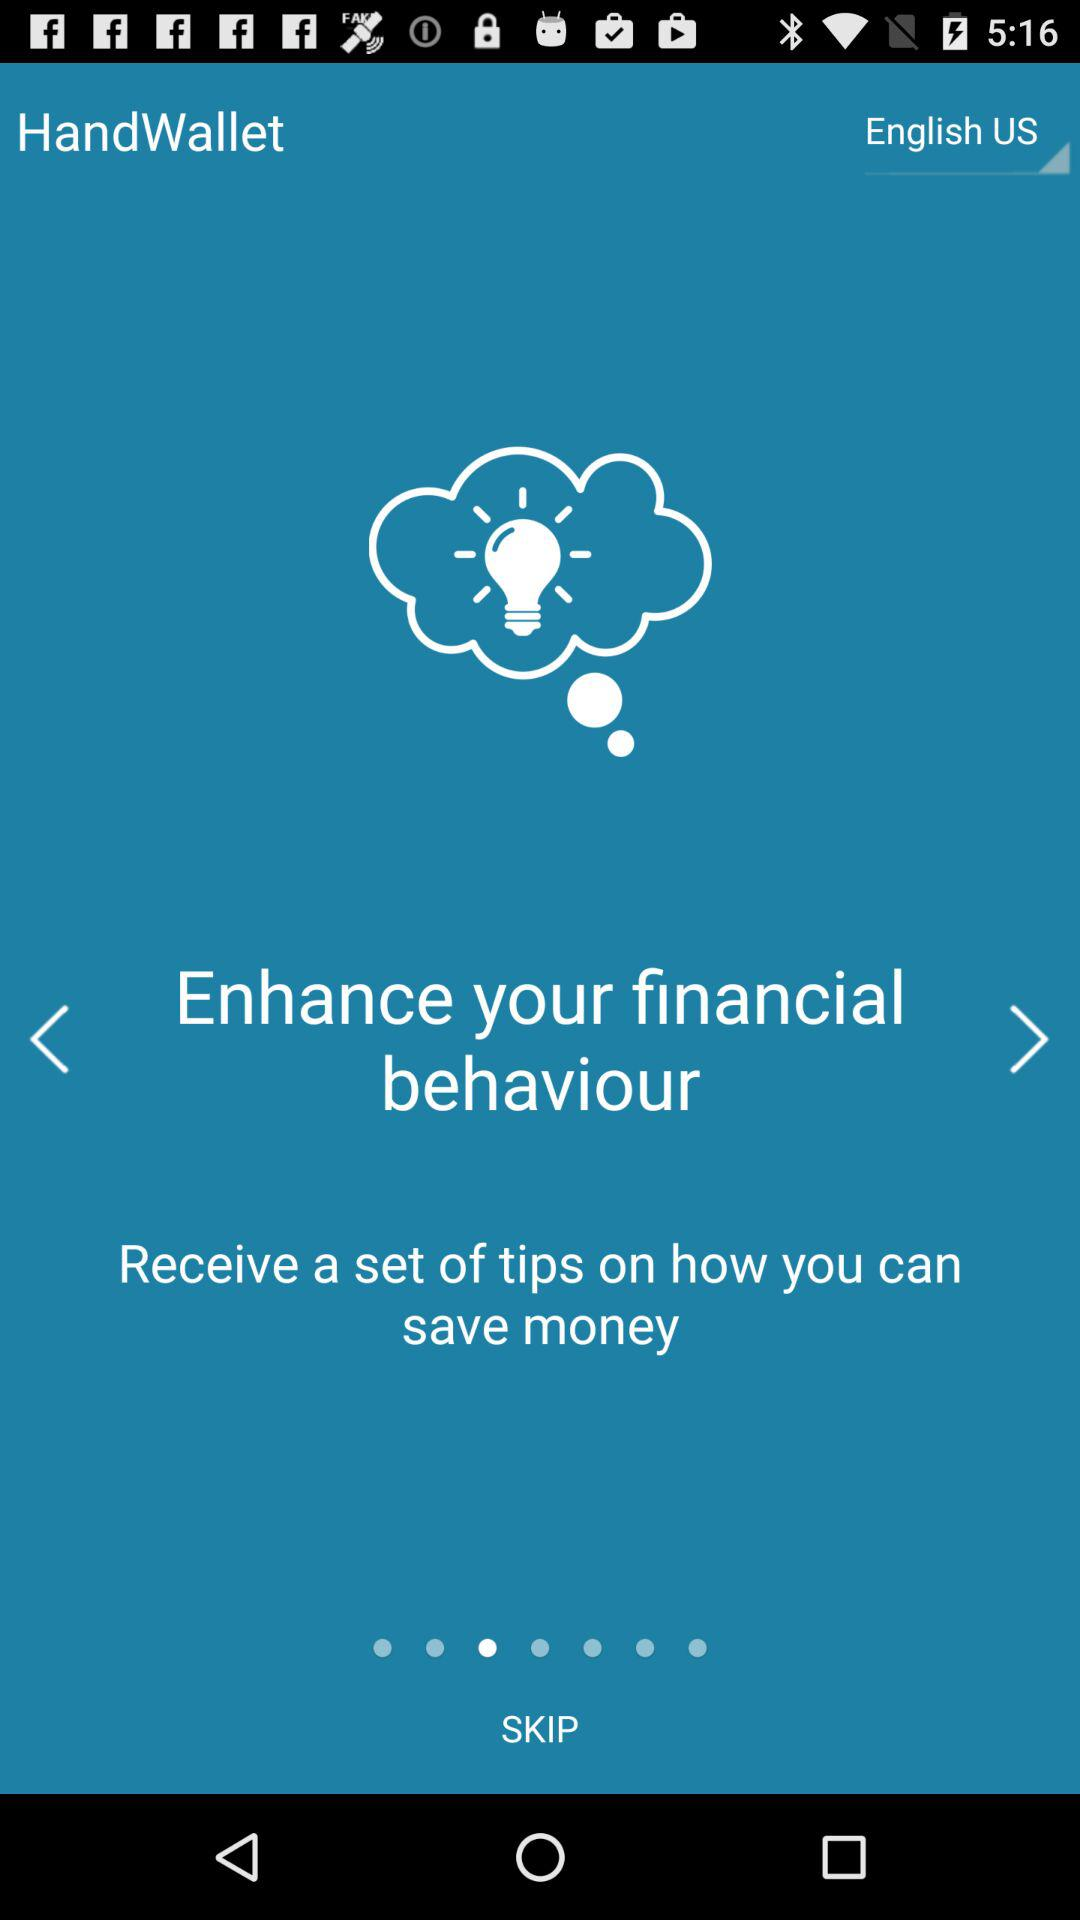Which tip is currently shown? The currently shown tip is "Enhance your financial behaviour". 